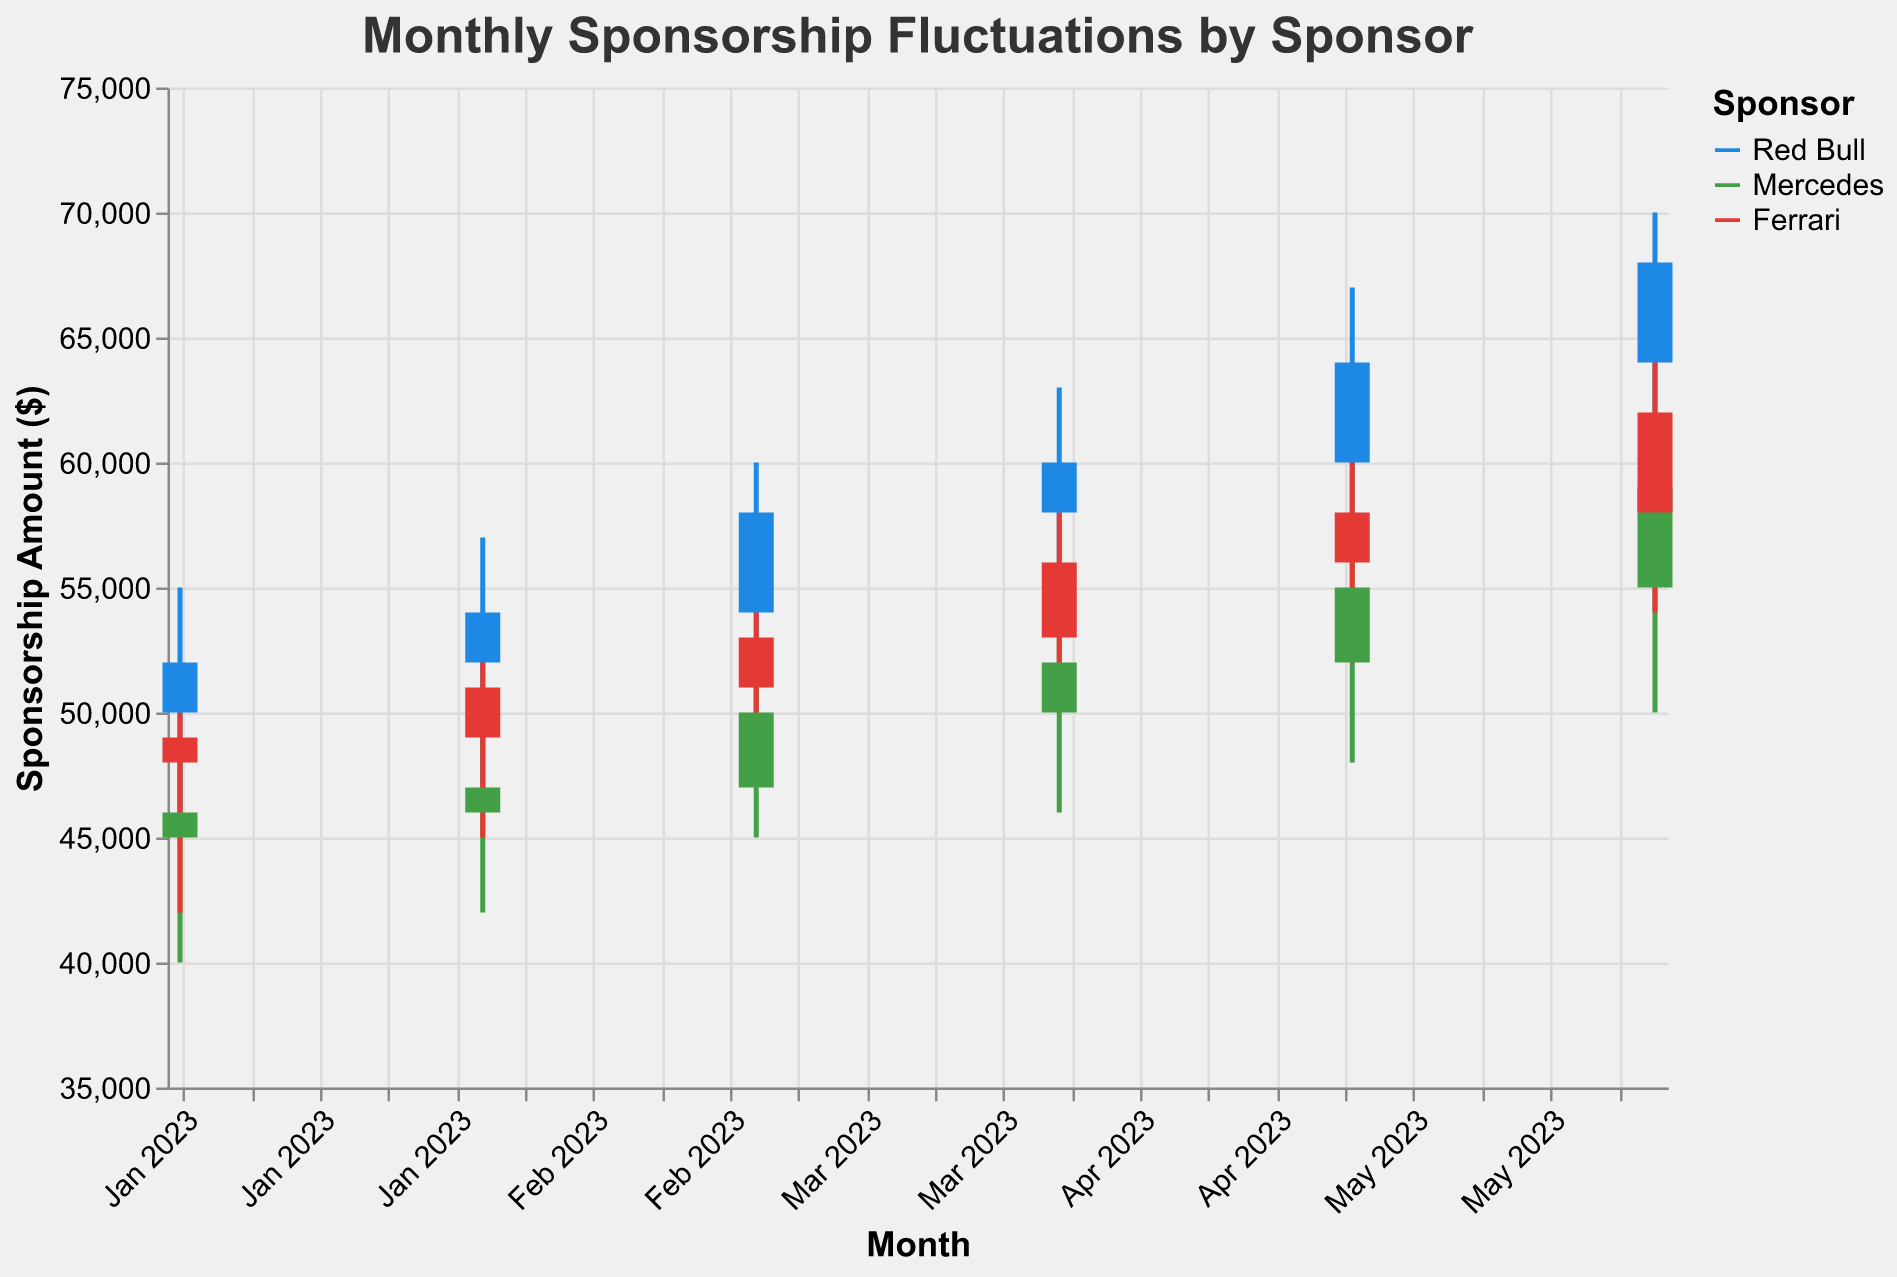What's the title of the figure? The title is usually displayed at the top of the figure. According to the provided code, the title is "Monthly Sponsorship Fluctuations by Sponsor".
Answer: Monthly Sponsorship Fluctuations by Sponsor Which sponsor had the highest Close amount in June 2023? To find which sponsor had the highest Close amount, look at the "Close" values for June 2023 entries and compare them. Red Bull had the highest Close amount of $68,000.
Answer: Red Bull What is the color legend for the sponsors? The color legend explains the colors associated with each sponsor. Red Bull is represented by blue, Mercedes by green, and Ferrari by red.
Answer: Red Bull: Blue, Mercedes: Green, Ferrari: Red What are the y-axis title and the units it represents? The y-axis title is "Sponsorship Amount ($)", and it represents the amounts in dollars.
Answer: Sponsorship Amount ($) From April 2023 to May 2023, did Mercedes' sponsorship Close amount increase or decrease? By how much? The Close amount for Mercedes in April 2023 was $52,000 and in May 2023 was $55,000. Therefore, the sponsorship amount increased by $3,000.
Answer: Increase, $3,000 Which month shows the highest High value for Ferrari? The highest High value for Ferrari can be seen in the month-by-month comparison of the "High" values. In June 2023, Ferrari's High value was $65,000, which is the highest.
Answer: June 2023 What is the range of sponsorship amounts for Red Bull in March 2023? To find the range for Red Bull in March 2023, subtract the Low amount from the High amount. High is $60,000, and Low is $50,000, so the range is $10,000.
Answer: $10,000 By how much did Red Bull's Close amount change from February 2023 to March 2023? The Close amount for Red Bull in February 2023 was $54,000 and in March 2023 was $58,000, which means there was a $4,000 increase.
Answer: $4,000 Which sponsor had the smallest range of fluctuations (High - Low) in January 2023, and what was the range? The range can be calculated by subtracting the Low value from the High value for each sponsor in January 2023. Mercedes' values are $48,000 (High) and $40,000 (Low), giving it the smallest range of $8,000.
Answer: Mercedes, $8,000 